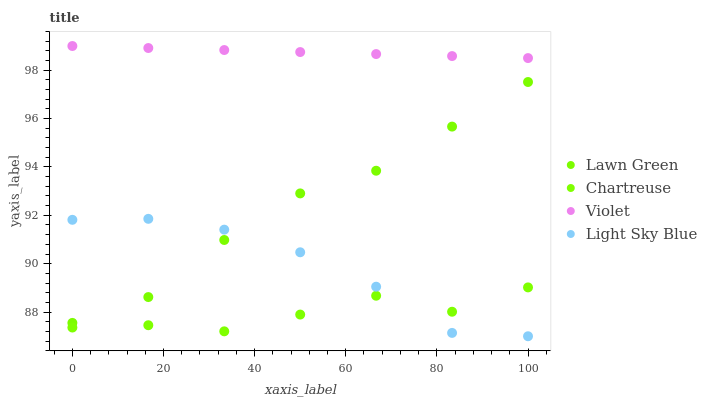Does Chartreuse have the minimum area under the curve?
Answer yes or no. Yes. Does Violet have the maximum area under the curve?
Answer yes or no. Yes. Does Light Sky Blue have the minimum area under the curve?
Answer yes or no. No. Does Light Sky Blue have the maximum area under the curve?
Answer yes or no. No. Is Violet the smoothest?
Answer yes or no. Yes. Is Chartreuse the roughest?
Answer yes or no. Yes. Is Light Sky Blue the smoothest?
Answer yes or no. No. Is Light Sky Blue the roughest?
Answer yes or no. No. Does Light Sky Blue have the lowest value?
Answer yes or no. Yes. Does Chartreuse have the lowest value?
Answer yes or no. No. Does Violet have the highest value?
Answer yes or no. Yes. Does Light Sky Blue have the highest value?
Answer yes or no. No. Is Chartreuse less than Lawn Green?
Answer yes or no. Yes. Is Violet greater than Lawn Green?
Answer yes or no. Yes. Does Lawn Green intersect Light Sky Blue?
Answer yes or no. Yes. Is Lawn Green less than Light Sky Blue?
Answer yes or no. No. Is Lawn Green greater than Light Sky Blue?
Answer yes or no. No. Does Chartreuse intersect Lawn Green?
Answer yes or no. No. 